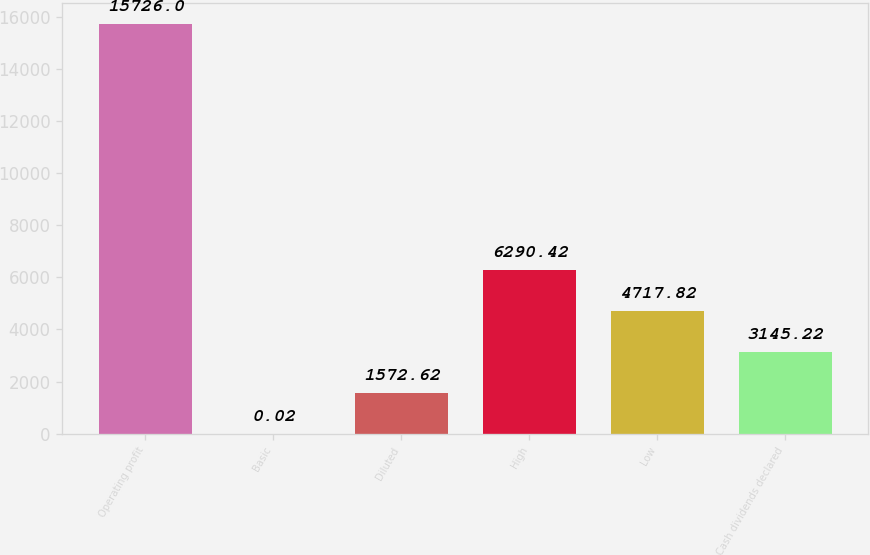Convert chart. <chart><loc_0><loc_0><loc_500><loc_500><bar_chart><fcel>Operating profit<fcel>Basic<fcel>Diluted<fcel>High<fcel>Low<fcel>Cash dividends declared<nl><fcel>15726<fcel>0.02<fcel>1572.62<fcel>6290.42<fcel>4717.82<fcel>3145.22<nl></chart> 